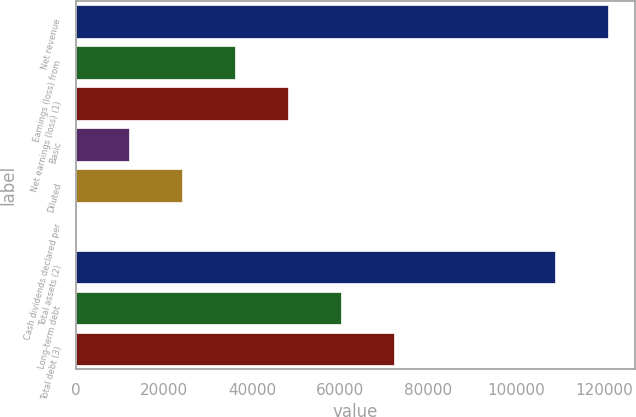<chart> <loc_0><loc_0><loc_500><loc_500><bar_chart><fcel>Net revenue<fcel>Earnings (loss) from<fcel>Net earnings (loss) (1)<fcel>Basic<fcel>Diluted<fcel>Cash dividends declared per<fcel>Total assets (2)<fcel>Long-term debt<fcel>Total debt (3)<nl><fcel>120804<fcel>36107.4<fcel>48143.1<fcel>12036.1<fcel>24071.8<fcel>0.5<fcel>108768<fcel>60178.8<fcel>72214.4<nl></chart> 